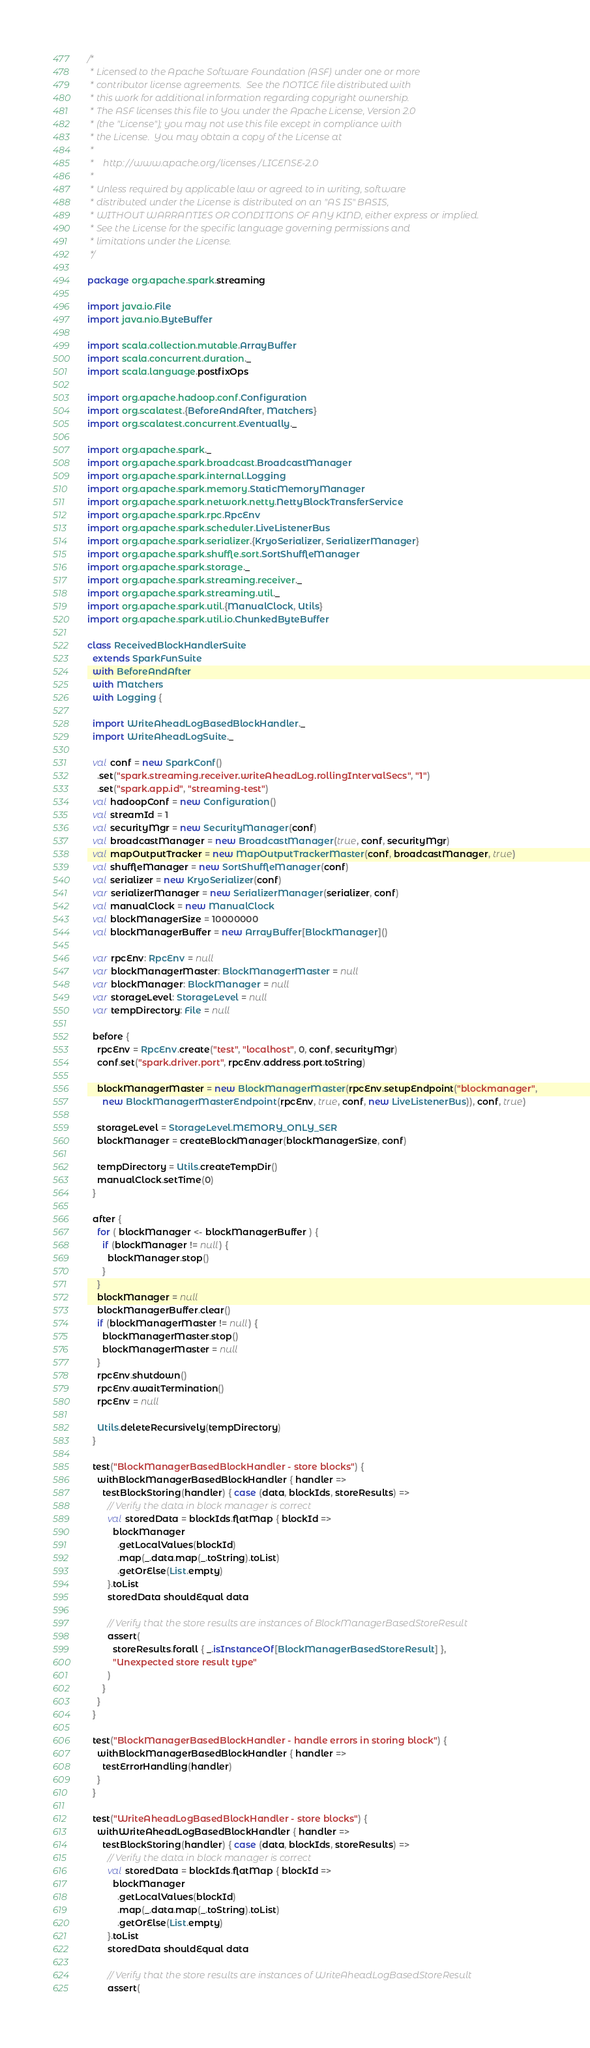<code> <loc_0><loc_0><loc_500><loc_500><_Scala_>/*
 * Licensed to the Apache Software Foundation (ASF) under one or more
 * contributor license agreements.  See the NOTICE file distributed with
 * this work for additional information regarding copyright ownership.
 * The ASF licenses this file to You under the Apache License, Version 2.0
 * (the "License"); you may not use this file except in compliance with
 * the License.  You may obtain a copy of the License at
 *
 *    http://www.apache.org/licenses/LICENSE-2.0
 *
 * Unless required by applicable law or agreed to in writing, software
 * distributed under the License is distributed on an "AS IS" BASIS,
 * WITHOUT WARRANTIES OR CONDITIONS OF ANY KIND, either express or implied.
 * See the License for the specific language governing permissions and
 * limitations under the License.
 */

package org.apache.spark.streaming

import java.io.File
import java.nio.ByteBuffer

import scala.collection.mutable.ArrayBuffer
import scala.concurrent.duration._
import scala.language.postfixOps

import org.apache.hadoop.conf.Configuration
import org.scalatest.{BeforeAndAfter, Matchers}
import org.scalatest.concurrent.Eventually._

import org.apache.spark._
import org.apache.spark.broadcast.BroadcastManager
import org.apache.spark.internal.Logging
import org.apache.spark.memory.StaticMemoryManager
import org.apache.spark.network.netty.NettyBlockTransferService
import org.apache.spark.rpc.RpcEnv
import org.apache.spark.scheduler.LiveListenerBus
import org.apache.spark.serializer.{KryoSerializer, SerializerManager}
import org.apache.spark.shuffle.sort.SortShuffleManager
import org.apache.spark.storage._
import org.apache.spark.streaming.receiver._
import org.apache.spark.streaming.util._
import org.apache.spark.util.{ManualClock, Utils}
import org.apache.spark.util.io.ChunkedByteBuffer

class ReceivedBlockHandlerSuite
  extends SparkFunSuite
  with BeforeAndAfter
  with Matchers
  with Logging {

  import WriteAheadLogBasedBlockHandler._
  import WriteAheadLogSuite._

  val conf = new SparkConf()
    .set("spark.streaming.receiver.writeAheadLog.rollingIntervalSecs", "1")
    .set("spark.app.id", "streaming-test")
  val hadoopConf = new Configuration()
  val streamId = 1
  val securityMgr = new SecurityManager(conf)
  val broadcastManager = new BroadcastManager(true, conf, securityMgr)
  val mapOutputTracker = new MapOutputTrackerMaster(conf, broadcastManager, true)
  val shuffleManager = new SortShuffleManager(conf)
  val serializer = new KryoSerializer(conf)
  var serializerManager = new SerializerManager(serializer, conf)
  val manualClock = new ManualClock
  val blockManagerSize = 10000000
  val blockManagerBuffer = new ArrayBuffer[BlockManager]()

  var rpcEnv: RpcEnv = null
  var blockManagerMaster: BlockManagerMaster = null
  var blockManager: BlockManager = null
  var storageLevel: StorageLevel = null
  var tempDirectory: File = null

  before {
    rpcEnv = RpcEnv.create("test", "localhost", 0, conf, securityMgr)
    conf.set("spark.driver.port", rpcEnv.address.port.toString)

    blockManagerMaster = new BlockManagerMaster(rpcEnv.setupEndpoint("blockmanager",
      new BlockManagerMasterEndpoint(rpcEnv, true, conf, new LiveListenerBus)), conf, true)

    storageLevel = StorageLevel.MEMORY_ONLY_SER
    blockManager = createBlockManager(blockManagerSize, conf)

    tempDirectory = Utils.createTempDir()
    manualClock.setTime(0)
  }

  after {
    for ( blockManager <- blockManagerBuffer ) {
      if (blockManager != null) {
        blockManager.stop()
      }
    }
    blockManager = null
    blockManagerBuffer.clear()
    if (blockManagerMaster != null) {
      blockManagerMaster.stop()
      blockManagerMaster = null
    }
    rpcEnv.shutdown()
    rpcEnv.awaitTermination()
    rpcEnv = null

    Utils.deleteRecursively(tempDirectory)
  }

  test("BlockManagerBasedBlockHandler - store blocks") {
    withBlockManagerBasedBlockHandler { handler =>
      testBlockStoring(handler) { case (data, blockIds, storeResults) =>
        // Verify the data in block manager is correct
        val storedData = blockIds.flatMap { blockId =>
          blockManager
            .getLocalValues(blockId)
            .map(_.data.map(_.toString).toList)
            .getOrElse(List.empty)
        }.toList
        storedData shouldEqual data

        // Verify that the store results are instances of BlockManagerBasedStoreResult
        assert(
          storeResults.forall { _.isInstanceOf[BlockManagerBasedStoreResult] },
          "Unexpected store result type"
        )
      }
    }
  }

  test("BlockManagerBasedBlockHandler - handle errors in storing block") {
    withBlockManagerBasedBlockHandler { handler =>
      testErrorHandling(handler)
    }
  }

  test("WriteAheadLogBasedBlockHandler - store blocks") {
    withWriteAheadLogBasedBlockHandler { handler =>
      testBlockStoring(handler) { case (data, blockIds, storeResults) =>
        // Verify the data in block manager is correct
        val storedData = blockIds.flatMap { blockId =>
          blockManager
            .getLocalValues(blockId)
            .map(_.data.map(_.toString).toList)
            .getOrElse(List.empty)
        }.toList
        storedData shouldEqual data

        // Verify that the store results are instances of WriteAheadLogBasedStoreResult
        assert(</code> 